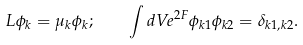<formula> <loc_0><loc_0><loc_500><loc_500>L \phi _ { k } = \mu _ { k } \phi _ { k } ; \quad \int d V e ^ { 2 F } \phi _ { k 1 } \phi _ { k 2 } = \delta _ { k 1 , k 2 } .</formula> 